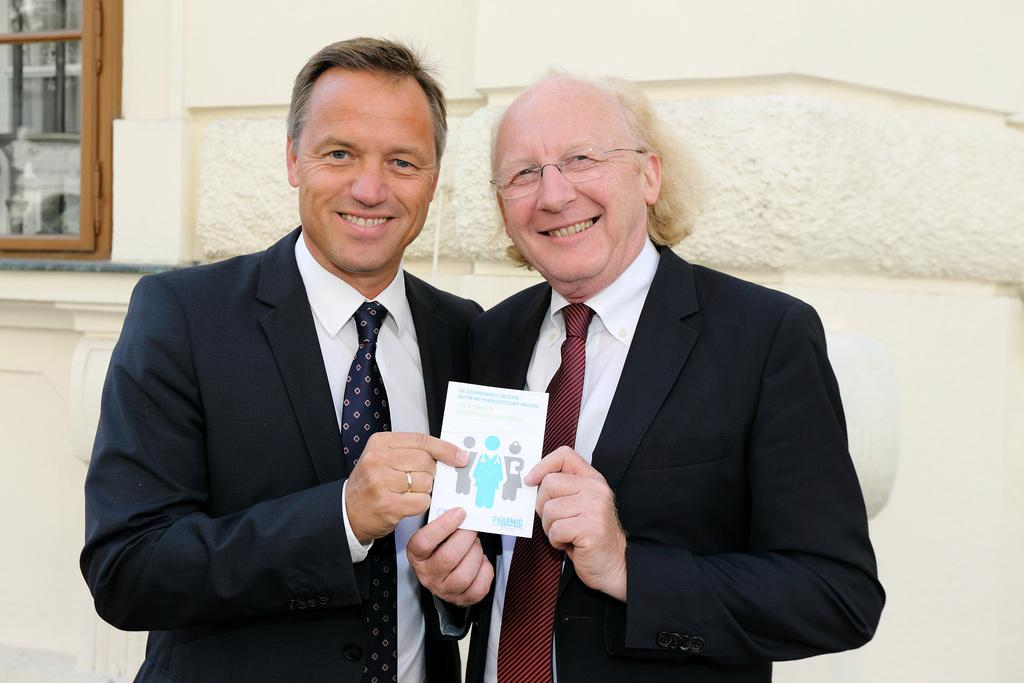How many people are in the image? There are two people in the image. What are the people doing in the image? The people are standing and holding a card. What can be seen in the background of the image? There is a wall in the background of the image. Is there any opening in the wall visible in the image? Yes, there is a window in the wall. What is the person's face of interest in the image? There is no mention of a person's face in the image, and the term "interest" is not relevant to the facts provided. --- Facts: 1. There is a car in the image. 2. The car is parked on the street. 3. There are trees on both sides of the street. 4. The sky is visible in the image. Absurd Topics: dance, ocean, birdhouse Conversation: What is the main subject of the image? The main subject of the image is a car. Where is the car located in the image? The car is parked on the street. What can be seen on both sides of the street in the image? There are trees on both sides of the street. What is visible in the background of the image? The sky is visible in the image. Reasoning: Let's think step by step in order to produce the conversation. We start by identifying the main subject in the image, which is the car. Then, we describe its location, which is on the street. Next, we mention the surrounding environment, which includes trees on both sides of the street. Finally, we focus on the background of the image, which is the sky. Absurd Question/Answer: Can you tell me how many birdhouses are hanging from the trees in the image? There is no mention of birdhouses in the image; the facts provided only mention trees. 